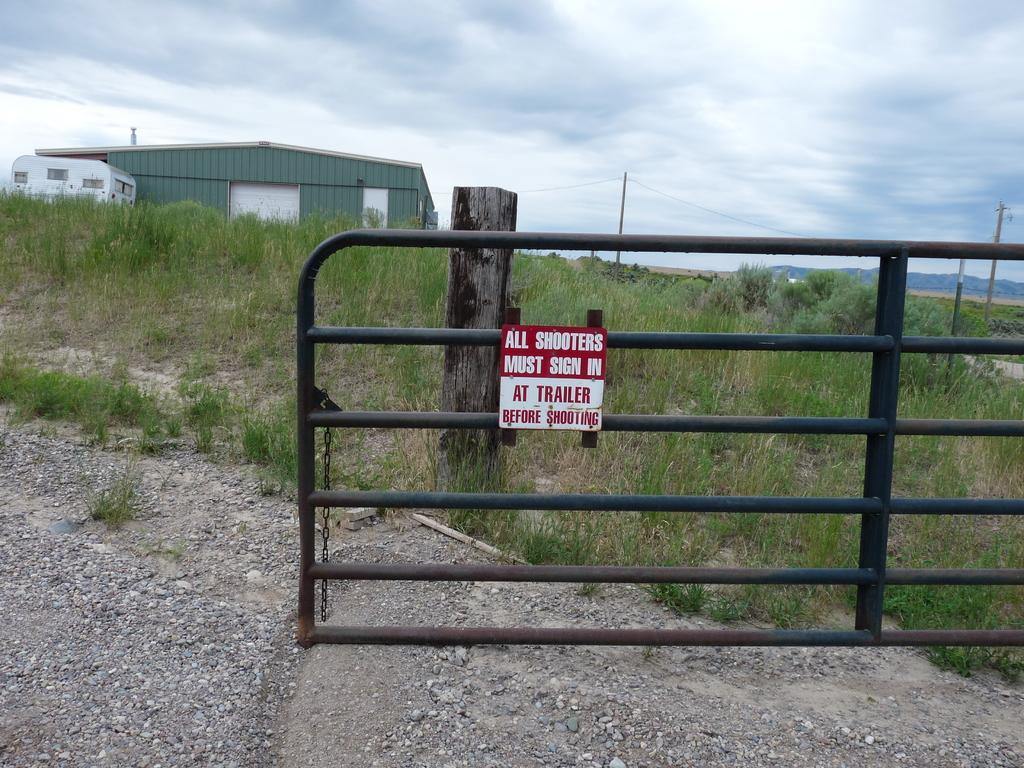Please provide a concise description of this image. In the center of the image we can see a barricade, board, house, grass, poles, wires are present. At the top of the image clouds are present in the sky. At the bottom of the image ground is there. 